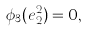Convert formula to latex. <formula><loc_0><loc_0><loc_500><loc_500>\phi _ { 3 } ( e ^ { 2 } _ { 2 } ) = 0 ,</formula> 